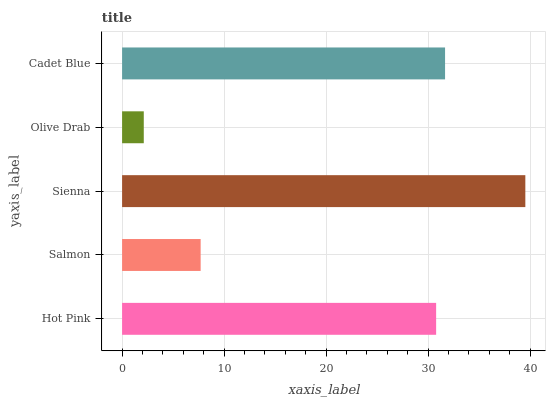Is Olive Drab the minimum?
Answer yes or no. Yes. Is Sienna the maximum?
Answer yes or no. Yes. Is Salmon the minimum?
Answer yes or no. No. Is Salmon the maximum?
Answer yes or no. No. Is Hot Pink greater than Salmon?
Answer yes or no. Yes. Is Salmon less than Hot Pink?
Answer yes or no. Yes. Is Salmon greater than Hot Pink?
Answer yes or no. No. Is Hot Pink less than Salmon?
Answer yes or no. No. Is Hot Pink the high median?
Answer yes or no. Yes. Is Hot Pink the low median?
Answer yes or no. Yes. Is Cadet Blue the high median?
Answer yes or no. No. Is Sienna the low median?
Answer yes or no. No. 